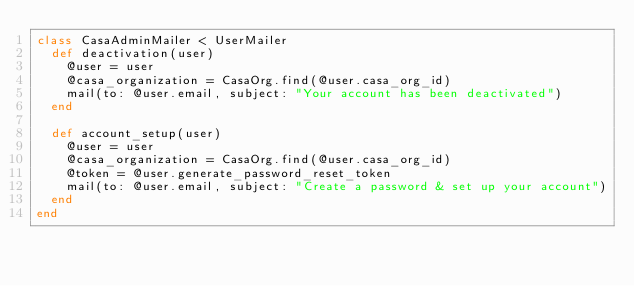<code> <loc_0><loc_0><loc_500><loc_500><_Ruby_>class CasaAdminMailer < UserMailer
  def deactivation(user)
    @user = user
    @casa_organization = CasaOrg.find(@user.casa_org_id)
    mail(to: @user.email, subject: "Your account has been deactivated")
  end

  def account_setup(user)
    @user = user
    @casa_organization = CasaOrg.find(@user.casa_org_id)
    @token = @user.generate_password_reset_token
    mail(to: @user.email, subject: "Create a password & set up your account")
  end
end
</code> 